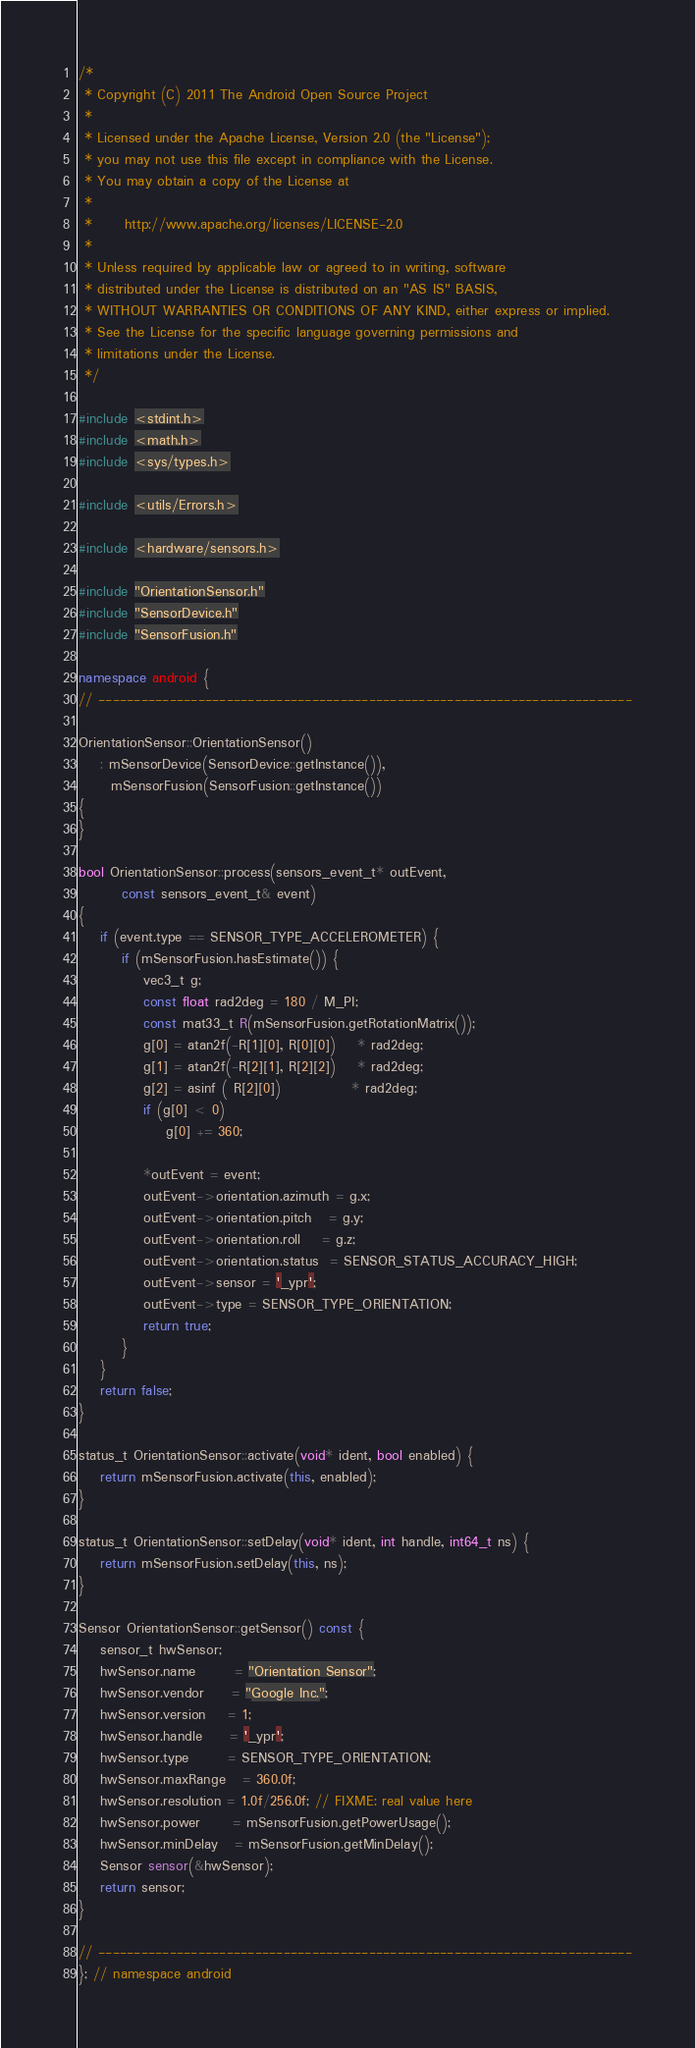Convert code to text. <code><loc_0><loc_0><loc_500><loc_500><_C++_>/*
 * Copyright (C) 2011 The Android Open Source Project
 *
 * Licensed under the Apache License, Version 2.0 (the "License");
 * you may not use this file except in compliance with the License.
 * You may obtain a copy of the License at
 *
 *      http://www.apache.org/licenses/LICENSE-2.0
 *
 * Unless required by applicable law or agreed to in writing, software
 * distributed under the License is distributed on an "AS IS" BASIS,
 * WITHOUT WARRANTIES OR CONDITIONS OF ANY KIND, either express or implied.
 * See the License for the specific language governing permissions and
 * limitations under the License.
 */

#include <stdint.h>
#include <math.h>
#include <sys/types.h>

#include <utils/Errors.h>

#include <hardware/sensors.h>

#include "OrientationSensor.h"
#include "SensorDevice.h"
#include "SensorFusion.h"

namespace android {
// ---------------------------------------------------------------------------

OrientationSensor::OrientationSensor()
    : mSensorDevice(SensorDevice::getInstance()),
      mSensorFusion(SensorFusion::getInstance())
{
}

bool OrientationSensor::process(sensors_event_t* outEvent,
        const sensors_event_t& event)
{
    if (event.type == SENSOR_TYPE_ACCELEROMETER) {
        if (mSensorFusion.hasEstimate()) {
            vec3_t g;
            const float rad2deg = 180 / M_PI;
            const mat33_t R(mSensorFusion.getRotationMatrix());
            g[0] = atan2f(-R[1][0], R[0][0])    * rad2deg;
            g[1] = atan2f(-R[2][1], R[2][2])    * rad2deg;
            g[2] = asinf ( R[2][0])             * rad2deg;
            if (g[0] < 0)
                g[0] += 360;

            *outEvent = event;
            outEvent->orientation.azimuth = g.x;
            outEvent->orientation.pitch   = g.y;
            outEvent->orientation.roll    = g.z;
            outEvent->orientation.status  = SENSOR_STATUS_ACCURACY_HIGH;
            outEvent->sensor = '_ypr';
            outEvent->type = SENSOR_TYPE_ORIENTATION;
            return true;
        }
    }
    return false;
}

status_t OrientationSensor::activate(void* ident, bool enabled) {
    return mSensorFusion.activate(this, enabled);
}

status_t OrientationSensor::setDelay(void* ident, int handle, int64_t ns) {
    return mSensorFusion.setDelay(this, ns);
}

Sensor OrientationSensor::getSensor() const {
    sensor_t hwSensor;
    hwSensor.name       = "Orientation Sensor";
    hwSensor.vendor     = "Google Inc.";
    hwSensor.version    = 1;
    hwSensor.handle     = '_ypr';
    hwSensor.type       = SENSOR_TYPE_ORIENTATION;
    hwSensor.maxRange   = 360.0f;
    hwSensor.resolution = 1.0f/256.0f; // FIXME: real value here
    hwSensor.power      = mSensorFusion.getPowerUsage();
    hwSensor.minDelay   = mSensorFusion.getMinDelay();
    Sensor sensor(&hwSensor);
    return sensor;
}

// ---------------------------------------------------------------------------
}; // namespace android

</code> 